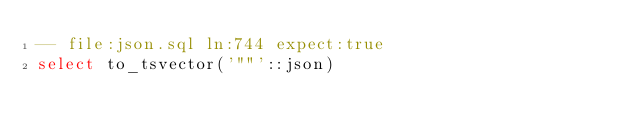<code> <loc_0><loc_0><loc_500><loc_500><_SQL_>-- file:json.sql ln:744 expect:true
select to_tsvector('""'::json)
</code> 